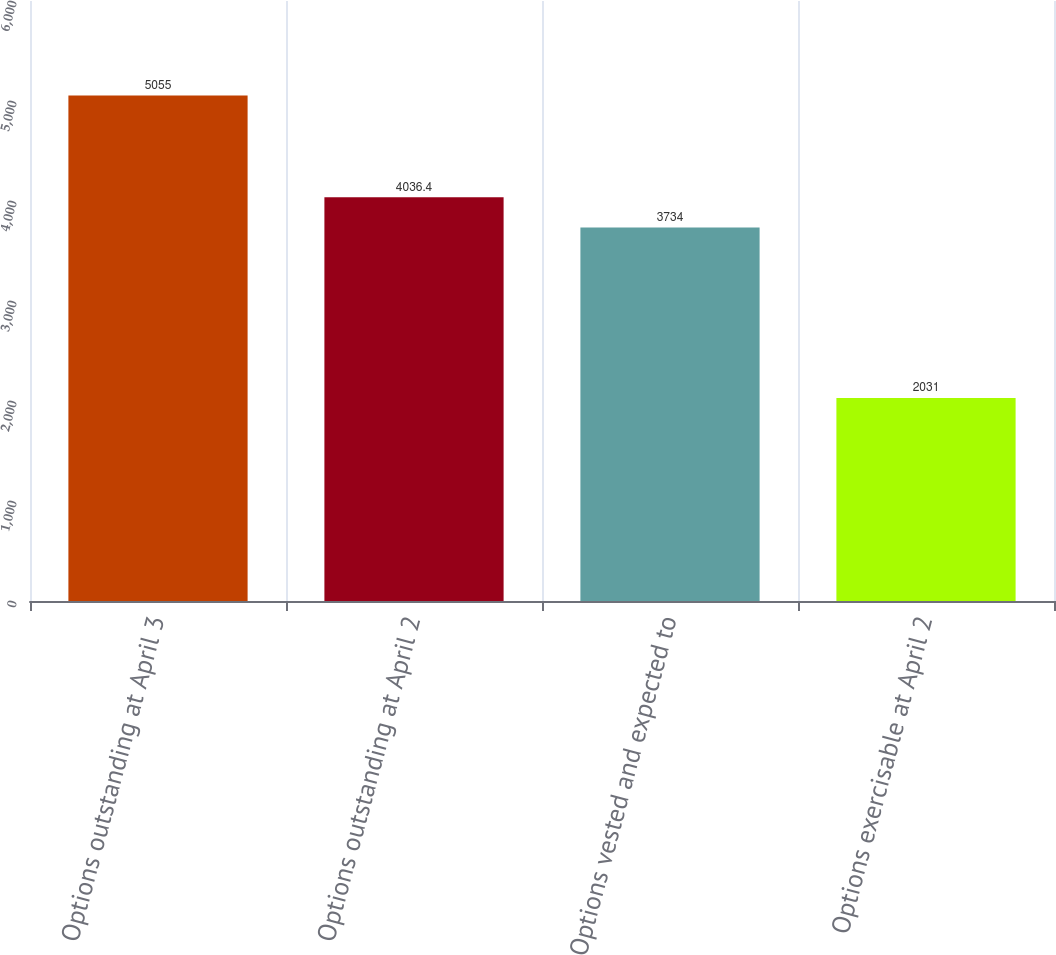Convert chart to OTSL. <chart><loc_0><loc_0><loc_500><loc_500><bar_chart><fcel>Options outstanding at April 3<fcel>Options outstanding at April 2<fcel>Options vested and expected to<fcel>Options exercisable at April 2<nl><fcel>5055<fcel>4036.4<fcel>3734<fcel>2031<nl></chart> 